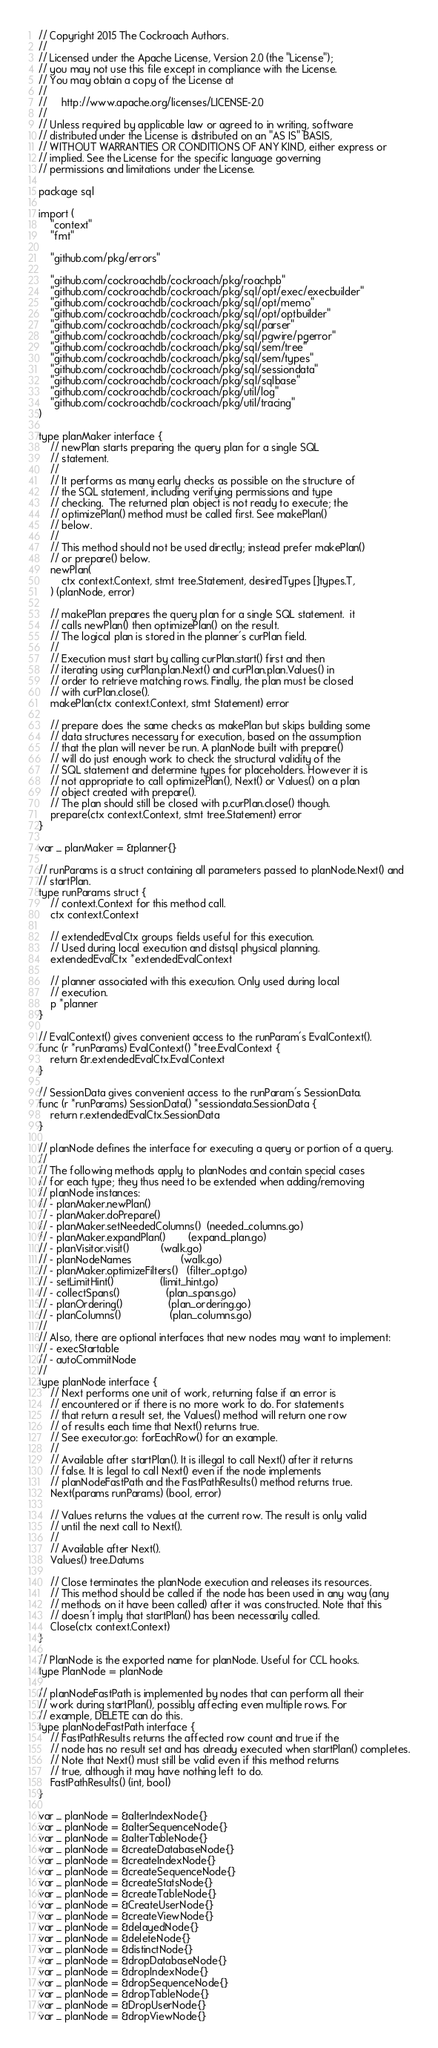Convert code to text. <code><loc_0><loc_0><loc_500><loc_500><_Go_>// Copyright 2015 The Cockroach Authors.
//
// Licensed under the Apache License, Version 2.0 (the "License");
// you may not use this file except in compliance with the License.
// You may obtain a copy of the License at
//
//     http://www.apache.org/licenses/LICENSE-2.0
//
// Unless required by applicable law or agreed to in writing, software
// distributed under the License is distributed on an "AS IS" BASIS,
// WITHOUT WARRANTIES OR CONDITIONS OF ANY KIND, either express or
// implied. See the License for the specific language governing
// permissions and limitations under the License.

package sql

import (
	"context"
	"fmt"

	"github.com/pkg/errors"

	"github.com/cockroachdb/cockroach/pkg/roachpb"
	"github.com/cockroachdb/cockroach/pkg/sql/opt/exec/execbuilder"
	"github.com/cockroachdb/cockroach/pkg/sql/opt/memo"
	"github.com/cockroachdb/cockroach/pkg/sql/opt/optbuilder"
	"github.com/cockroachdb/cockroach/pkg/sql/parser"
	"github.com/cockroachdb/cockroach/pkg/sql/pgwire/pgerror"
	"github.com/cockroachdb/cockroach/pkg/sql/sem/tree"
	"github.com/cockroachdb/cockroach/pkg/sql/sem/types"
	"github.com/cockroachdb/cockroach/pkg/sql/sessiondata"
	"github.com/cockroachdb/cockroach/pkg/sql/sqlbase"
	"github.com/cockroachdb/cockroach/pkg/util/log"
	"github.com/cockroachdb/cockroach/pkg/util/tracing"
)

type planMaker interface {
	// newPlan starts preparing the query plan for a single SQL
	// statement.
	//
	// It performs as many early checks as possible on the structure of
	// the SQL statement, including verifying permissions and type
	// checking.  The returned plan object is not ready to execute; the
	// optimizePlan() method must be called first. See makePlan()
	// below.
	//
	// This method should not be used directly; instead prefer makePlan()
	// or prepare() below.
	newPlan(
		ctx context.Context, stmt tree.Statement, desiredTypes []types.T,
	) (planNode, error)

	// makePlan prepares the query plan for a single SQL statement.  it
	// calls newPlan() then optimizePlan() on the result.
	// The logical plan is stored in the planner's curPlan field.
	//
	// Execution must start by calling curPlan.start() first and then
	// iterating using curPlan.plan.Next() and curPlan.plan.Values() in
	// order to retrieve matching rows. Finally, the plan must be closed
	// with curPlan.close().
	makePlan(ctx context.Context, stmt Statement) error

	// prepare does the same checks as makePlan but skips building some
	// data structures necessary for execution, based on the assumption
	// that the plan will never be run. A planNode built with prepare()
	// will do just enough work to check the structural validity of the
	// SQL statement and determine types for placeholders. However it is
	// not appropriate to call optimizePlan(), Next() or Values() on a plan
	// object created with prepare().
	// The plan should still be closed with p.curPlan.close() though.
	prepare(ctx context.Context, stmt tree.Statement) error
}

var _ planMaker = &planner{}

// runParams is a struct containing all parameters passed to planNode.Next() and
// startPlan.
type runParams struct {
	// context.Context for this method call.
	ctx context.Context

	// extendedEvalCtx groups fields useful for this execution.
	// Used during local execution and distsql physical planning.
	extendedEvalCtx *extendedEvalContext

	// planner associated with this execution. Only used during local
	// execution.
	p *planner
}

// EvalContext() gives convenient access to the runParam's EvalContext().
func (r *runParams) EvalContext() *tree.EvalContext {
	return &r.extendedEvalCtx.EvalContext
}

// SessionData gives convenient access to the runParam's SessionData.
func (r *runParams) SessionData() *sessiondata.SessionData {
	return r.extendedEvalCtx.SessionData
}

// planNode defines the interface for executing a query or portion of a query.
//
// The following methods apply to planNodes and contain special cases
// for each type; they thus need to be extended when adding/removing
// planNode instances:
// - planMaker.newPlan()
// - planMaker.doPrepare()
// - planMaker.setNeededColumns()  (needed_columns.go)
// - planMaker.expandPlan()        (expand_plan.go)
// - planVisitor.visit()           (walk.go)
// - planNodeNames                 (walk.go)
// - planMaker.optimizeFilters()   (filter_opt.go)
// - setLimitHint()                (limit_hint.go)
// - collectSpans()                (plan_spans.go)
// - planOrdering()                (plan_ordering.go)
// - planColumns()                 (plan_columns.go)
//
// Also, there are optional interfaces that new nodes may want to implement:
// - execStartable
// - autoCommitNode
//
type planNode interface {
	// Next performs one unit of work, returning false if an error is
	// encountered or if there is no more work to do. For statements
	// that return a result set, the Values() method will return one row
	// of results each time that Next() returns true.
	// See executor.go: forEachRow() for an example.
	//
	// Available after startPlan(). It is illegal to call Next() after it returns
	// false. It is legal to call Next() even if the node implements
	// planNodeFastPath and the FastPathResults() method returns true.
	Next(params runParams) (bool, error)

	// Values returns the values at the current row. The result is only valid
	// until the next call to Next().
	//
	// Available after Next().
	Values() tree.Datums

	// Close terminates the planNode execution and releases its resources.
	// This method should be called if the node has been used in any way (any
	// methods on it have been called) after it was constructed. Note that this
	// doesn't imply that startPlan() has been necessarily called.
	Close(ctx context.Context)
}

// PlanNode is the exported name for planNode. Useful for CCL hooks.
type PlanNode = planNode

// planNodeFastPath is implemented by nodes that can perform all their
// work during startPlan(), possibly affecting even multiple rows. For
// example, DELETE can do this.
type planNodeFastPath interface {
	// FastPathResults returns the affected row count and true if the
	// node has no result set and has already executed when startPlan() completes.
	// Note that Next() must still be valid even if this method returns
	// true, although it may have nothing left to do.
	FastPathResults() (int, bool)
}

var _ planNode = &alterIndexNode{}
var _ planNode = &alterSequenceNode{}
var _ planNode = &alterTableNode{}
var _ planNode = &createDatabaseNode{}
var _ planNode = &createIndexNode{}
var _ planNode = &createSequenceNode{}
var _ planNode = &createStatsNode{}
var _ planNode = &createTableNode{}
var _ planNode = &CreateUserNode{}
var _ planNode = &createViewNode{}
var _ planNode = &delayedNode{}
var _ planNode = &deleteNode{}
var _ planNode = &distinctNode{}
var _ planNode = &dropDatabaseNode{}
var _ planNode = &dropIndexNode{}
var _ planNode = &dropSequenceNode{}
var _ planNode = &dropTableNode{}
var _ planNode = &DropUserNode{}
var _ planNode = &dropViewNode{}</code> 